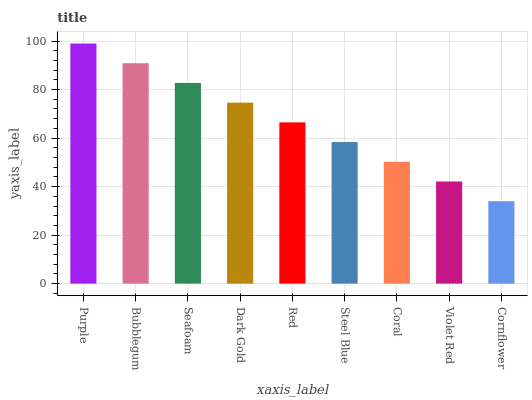Is Cornflower the minimum?
Answer yes or no. Yes. Is Purple the maximum?
Answer yes or no. Yes. Is Bubblegum the minimum?
Answer yes or no. No. Is Bubblegum the maximum?
Answer yes or no. No. Is Purple greater than Bubblegum?
Answer yes or no. Yes. Is Bubblegum less than Purple?
Answer yes or no. Yes. Is Bubblegum greater than Purple?
Answer yes or no. No. Is Purple less than Bubblegum?
Answer yes or no. No. Is Red the high median?
Answer yes or no. Yes. Is Red the low median?
Answer yes or no. Yes. Is Violet Red the high median?
Answer yes or no. No. Is Seafoam the low median?
Answer yes or no. No. 